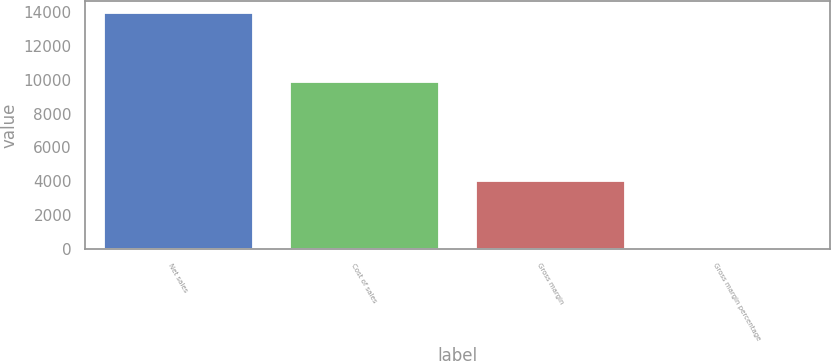Convert chart to OTSL. <chart><loc_0><loc_0><loc_500><loc_500><bar_chart><fcel>Net sales<fcel>Cost of sales<fcel>Gross margin<fcel>Gross margin percentage<nl><fcel>13931<fcel>9888<fcel>4043<fcel>29<nl></chart> 